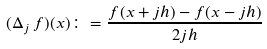<formula> <loc_0><loc_0><loc_500><loc_500>( \Delta _ { j } \, f ) ( x ) \colon = \frac { f ( x + j h ) - f ( x - j h ) } { 2 j h }</formula> 